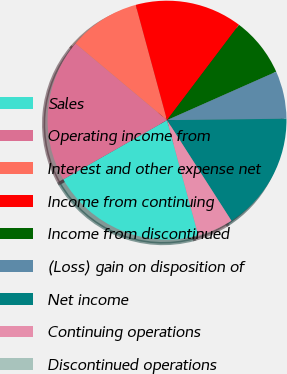Convert chart. <chart><loc_0><loc_0><loc_500><loc_500><pie_chart><fcel>Sales<fcel>Operating income from<fcel>Interest and other expense net<fcel>Income from continuing<fcel>Income from discontinued<fcel>(Loss) gain on disposition of<fcel>Net income<fcel>Continuing operations<fcel>Discontinued operations<nl><fcel>20.97%<fcel>19.35%<fcel>9.68%<fcel>14.52%<fcel>8.06%<fcel>6.45%<fcel>16.13%<fcel>4.84%<fcel>0.0%<nl></chart> 